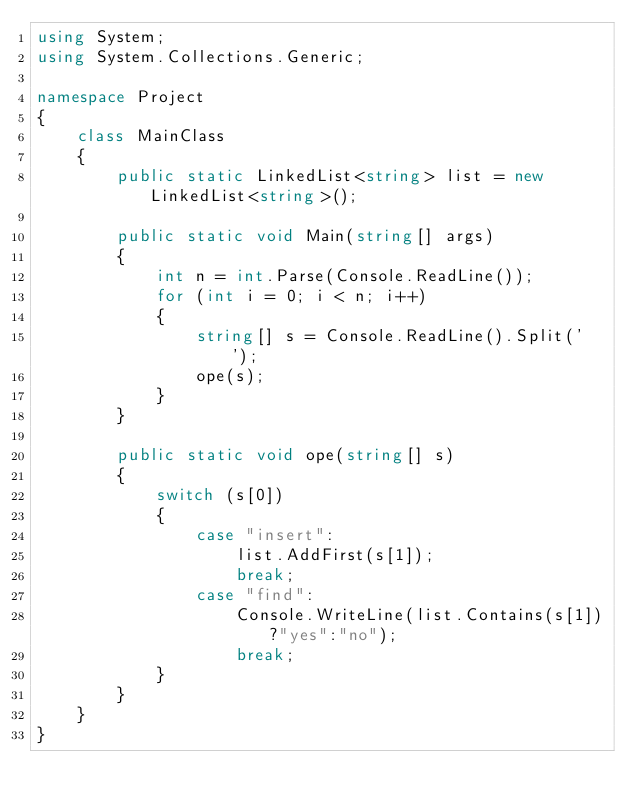Convert code to text. <code><loc_0><loc_0><loc_500><loc_500><_C#_>using System;
using System.Collections.Generic;

namespace Project
{
	class MainClass
	{
		public static LinkedList<string> list = new LinkedList<string>();

		public static void Main(string[] args)
		{
			int n = int.Parse(Console.ReadLine());
			for (int i = 0; i < n; i++)
			{
				string[] s = Console.ReadLine().Split(' ');
				ope(s);
			}
		}

		public static void ope(string[] s)
		{
			switch (s[0])
			{
				case "insert":
					list.AddFirst(s[1]);
					break;
				case "find":
					Console.WriteLine(list.Contains(s[1])?"yes":"no");
					break;
			}
		}
	}
}</code> 